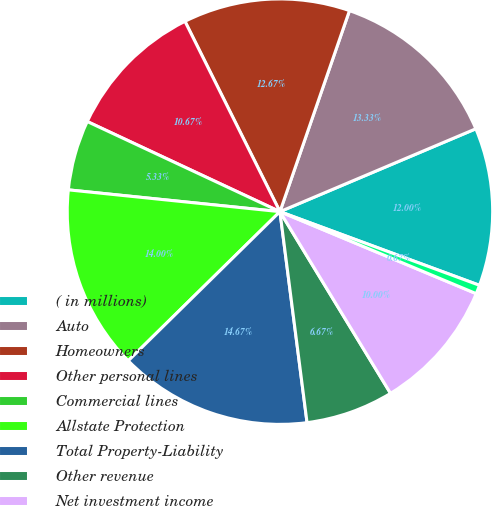<chart> <loc_0><loc_0><loc_500><loc_500><pie_chart><fcel>( in millions)<fcel>Auto<fcel>Homeowners<fcel>Other personal lines<fcel>Commercial lines<fcel>Allstate Protection<fcel>Total Property-Liability<fcel>Other revenue<fcel>Net investment income<fcel>Realized capital gains and<nl><fcel>12.0%<fcel>13.33%<fcel>12.67%<fcel>10.67%<fcel>5.33%<fcel>14.0%<fcel>14.67%<fcel>6.67%<fcel>10.0%<fcel>0.67%<nl></chart> 